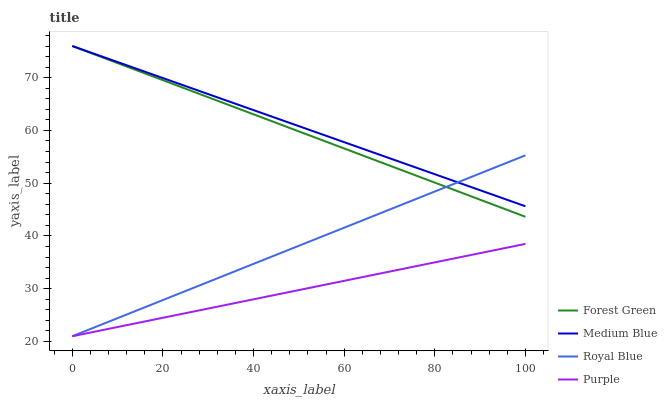Does Purple have the minimum area under the curve?
Answer yes or no. Yes. Does Medium Blue have the maximum area under the curve?
Answer yes or no. Yes. Does Royal Blue have the minimum area under the curve?
Answer yes or no. No. Does Royal Blue have the maximum area under the curve?
Answer yes or no. No. Is Purple the smoothest?
Answer yes or no. Yes. Is Forest Green the roughest?
Answer yes or no. Yes. Is Royal Blue the smoothest?
Answer yes or no. No. Is Royal Blue the roughest?
Answer yes or no. No. Does Purple have the lowest value?
Answer yes or no. Yes. Does Forest Green have the lowest value?
Answer yes or no. No. Does Medium Blue have the highest value?
Answer yes or no. Yes. Does Royal Blue have the highest value?
Answer yes or no. No. Is Purple less than Medium Blue?
Answer yes or no. Yes. Is Medium Blue greater than Purple?
Answer yes or no. Yes. Does Royal Blue intersect Forest Green?
Answer yes or no. Yes. Is Royal Blue less than Forest Green?
Answer yes or no. No. Is Royal Blue greater than Forest Green?
Answer yes or no. No. Does Purple intersect Medium Blue?
Answer yes or no. No. 